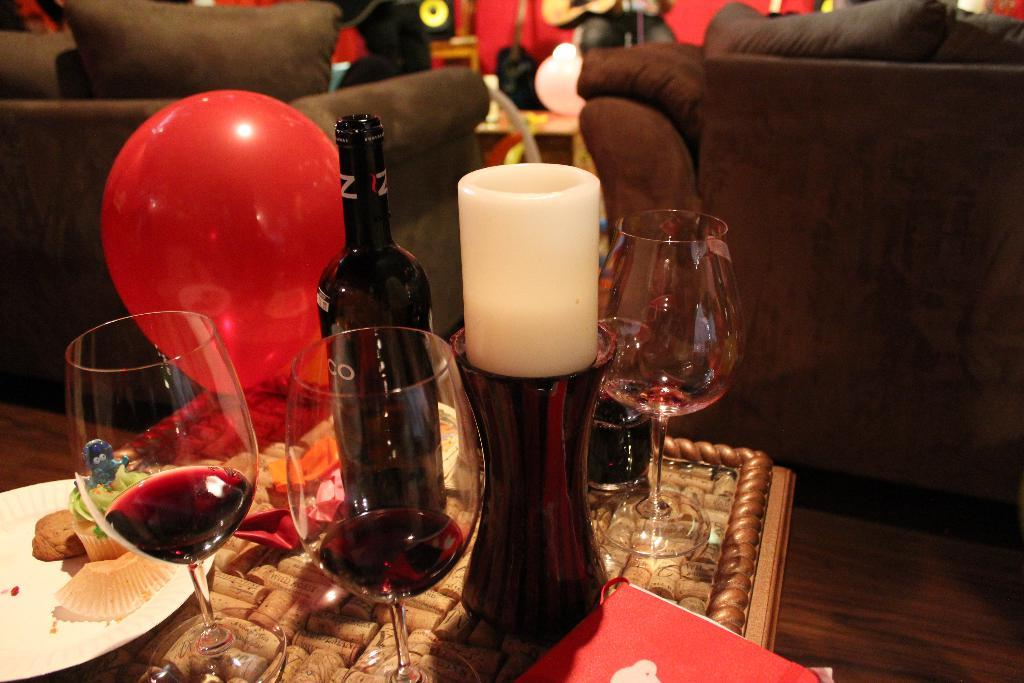What type of furniture is in the image? There is a sofa in the image. What other piece of furniture is in the image? There is a table in the image. What can be seen on the table? A wine glass, a candle, and a balloon are present on the table. Is there any food visible in the image? Yes, there is a plate with food in the image. Can you tell me how many toads are sitting on the sofa in the image? There are no toads present in the image; it only features a sofa, a table, and various objects on the table. 